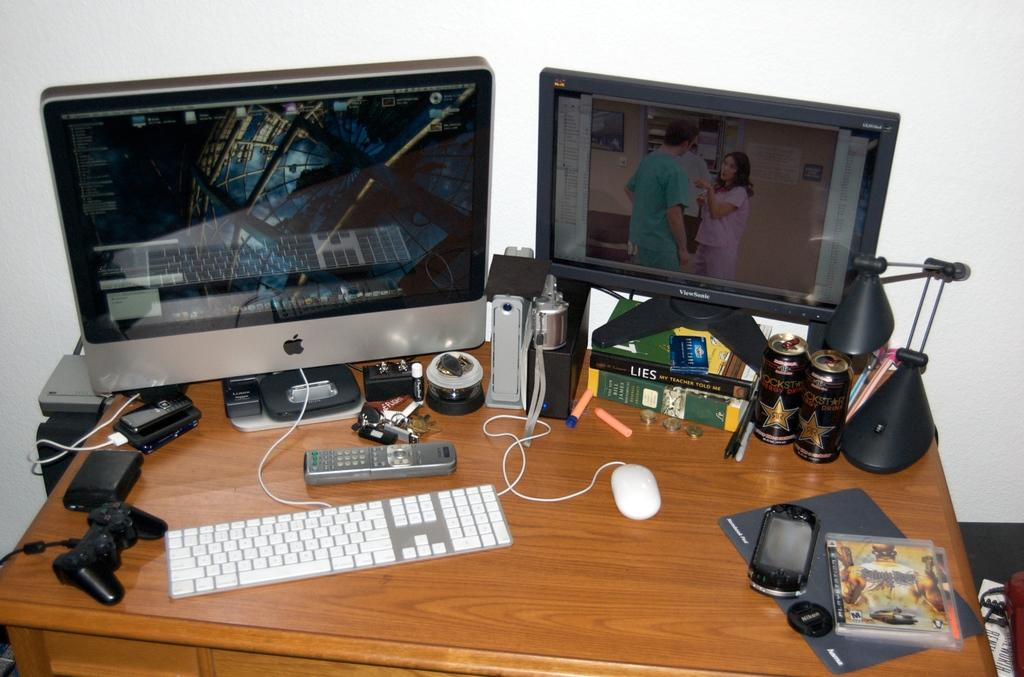What type of electronic device is visible in the image? There is a monitor in the image. What is used for input with the monitor? There is a keyboard and a mouse in the image. What other objects can be seen on the table? There is a remote, keys, a mobile phone, tins, a table lamp, books, and pens in the image. Can you tell me how many farmers are present in the image? There are no farmers present in the image. What type of patch is visible on the table in the image? There is no patch visible on the table in the image. 